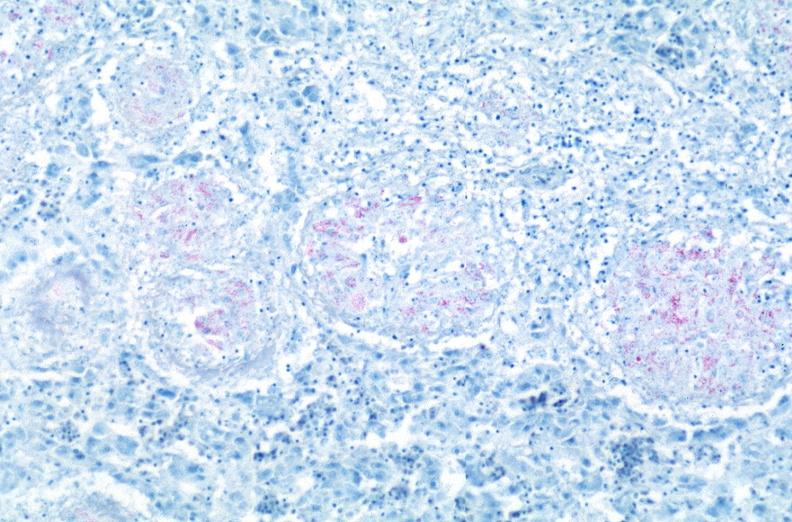where is this?
Answer the question using a single word or phrase. Lung 